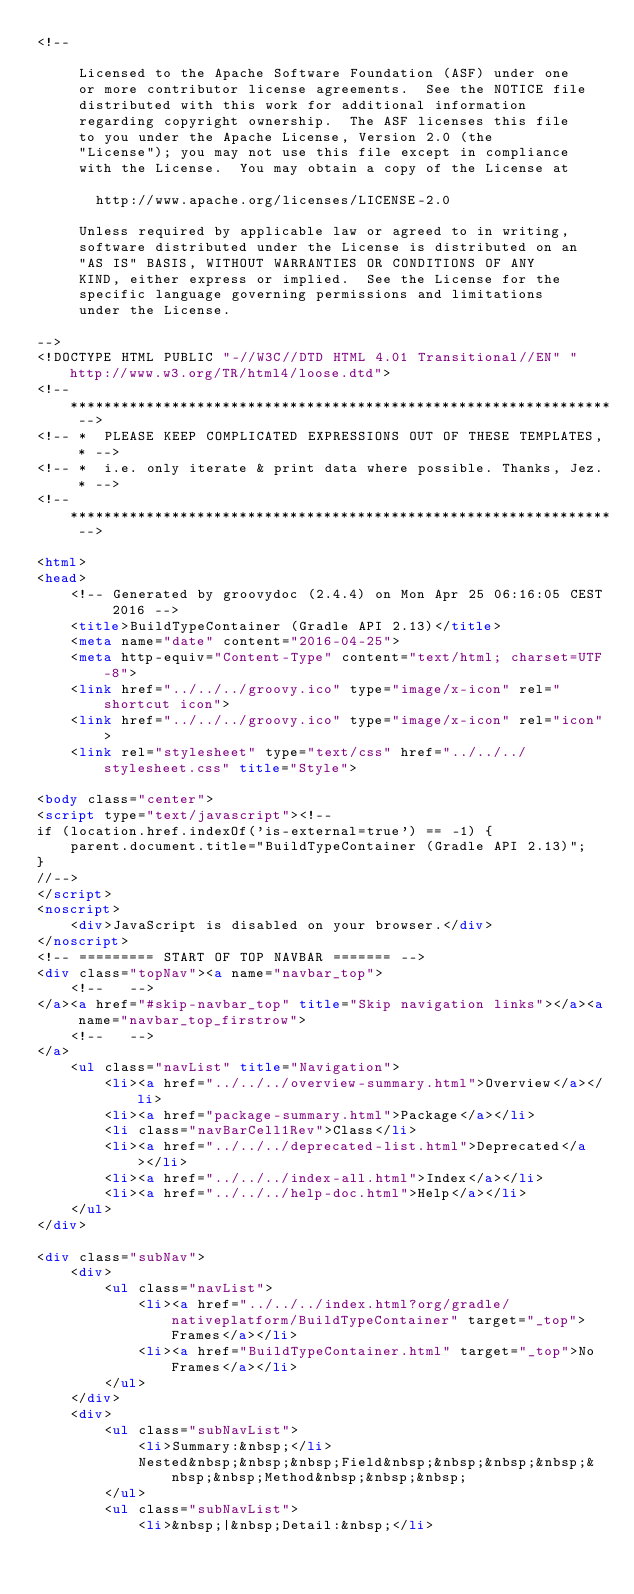<code> <loc_0><loc_0><loc_500><loc_500><_HTML_><!--

     Licensed to the Apache Software Foundation (ASF) under one
     or more contributor license agreements.  See the NOTICE file
     distributed with this work for additional information
     regarding copyright ownership.  The ASF licenses this file
     to you under the Apache License, Version 2.0 (the
     "License"); you may not use this file except in compliance
     with the License.  You may obtain a copy of the License at

       http://www.apache.org/licenses/LICENSE-2.0

     Unless required by applicable law or agreed to in writing,
     software distributed under the License is distributed on an
     "AS IS" BASIS, WITHOUT WARRANTIES OR CONDITIONS OF ANY
     KIND, either express or implied.  See the License for the
     specific language governing permissions and limitations
     under the License.

-->
<!DOCTYPE HTML PUBLIC "-//W3C//DTD HTML 4.01 Transitional//EN" "http://www.w3.org/TR/html4/loose.dtd">
<!-- **************************************************************** -->
<!-- *  PLEASE KEEP COMPLICATED EXPRESSIONS OUT OF THESE TEMPLATES, * -->
<!-- *  i.e. only iterate & print data where possible. Thanks, Jez. * -->
<!-- **************************************************************** -->

<html>
<head>
    <!-- Generated by groovydoc (2.4.4) on Mon Apr 25 06:16:05 CEST 2016 -->
    <title>BuildTypeContainer (Gradle API 2.13)</title>
    <meta name="date" content="2016-04-25">
    <meta http-equiv="Content-Type" content="text/html; charset=UTF-8">
    <link href="../../../groovy.ico" type="image/x-icon" rel="shortcut icon">
    <link href="../../../groovy.ico" type="image/x-icon" rel="icon">
    <link rel="stylesheet" type="text/css" href="../../../stylesheet.css" title="Style">

<body class="center">
<script type="text/javascript"><!--
if (location.href.indexOf('is-external=true') == -1) {
    parent.document.title="BuildTypeContainer (Gradle API 2.13)";
}
//-->
</script>
<noscript>
    <div>JavaScript is disabled on your browser.</div>
</noscript>
<!-- ========= START OF TOP NAVBAR ======= -->
<div class="topNav"><a name="navbar_top">
    <!--   -->
</a><a href="#skip-navbar_top" title="Skip navigation links"></a><a name="navbar_top_firstrow">
    <!--   -->
</a>
    <ul class="navList" title="Navigation">
        <li><a href="../../../overview-summary.html">Overview</a></li>
        <li><a href="package-summary.html">Package</a></li>
        <li class="navBarCell1Rev">Class</li>
        <li><a href="../../../deprecated-list.html">Deprecated</a></li>
        <li><a href="../../../index-all.html">Index</a></li>
        <li><a href="../../../help-doc.html">Help</a></li>
    </ul>
</div>

<div class="subNav">
    <div>
        <ul class="navList">
            <li><a href="../../../index.html?org/gradle/nativeplatform/BuildTypeContainer" target="_top">Frames</a></li>
            <li><a href="BuildTypeContainer.html" target="_top">No Frames</a></li>
        </ul>
    </div>
    <div>
        <ul class="subNavList">
            <li>Summary:&nbsp;</li>
            Nested&nbsp;&nbsp;&nbsp;Field&nbsp;&nbsp;&nbsp;&nbsp;&nbsp;&nbsp;Method&nbsp;&nbsp;&nbsp;
        </ul>
        <ul class="subNavList">
            <li>&nbsp;|&nbsp;Detail:&nbsp;</li></code> 